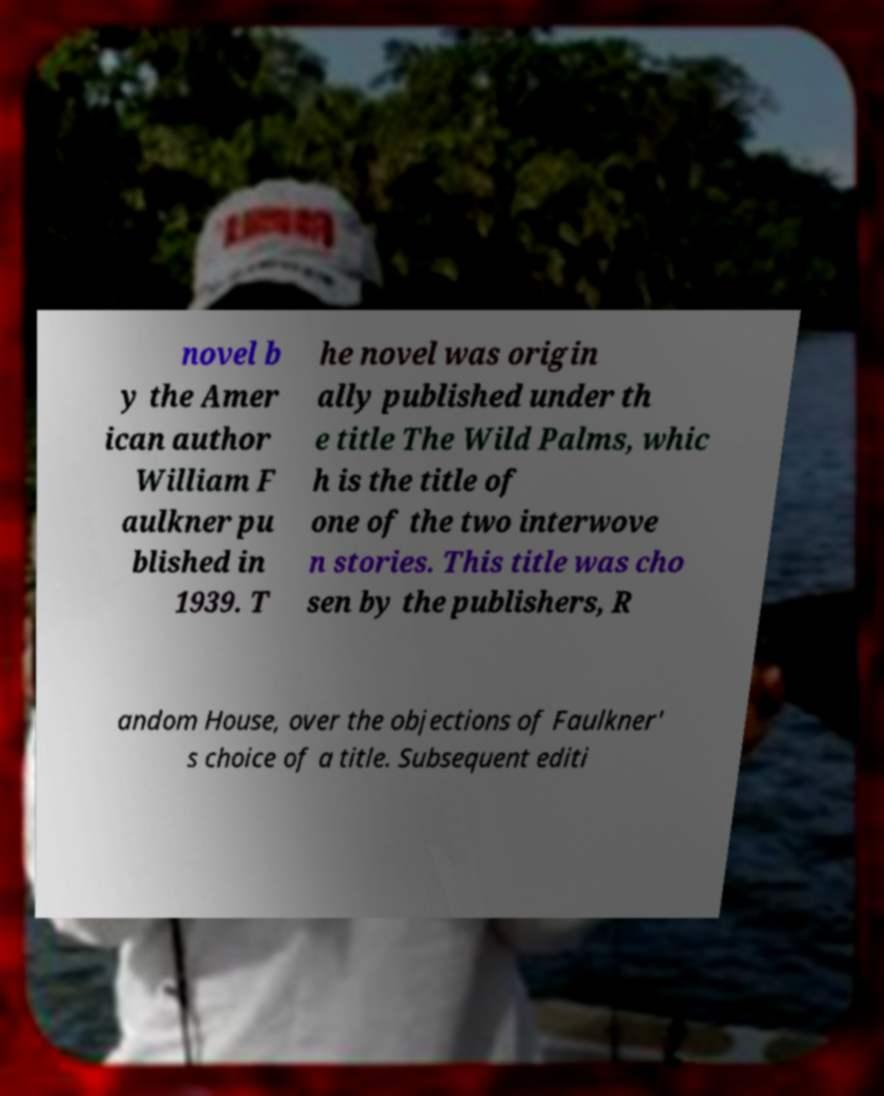Could you extract and type out the text from this image? novel b y the Amer ican author William F aulkner pu blished in 1939. T he novel was origin ally published under th e title The Wild Palms, whic h is the title of one of the two interwove n stories. This title was cho sen by the publishers, R andom House, over the objections of Faulkner' s choice of a title. Subsequent editi 